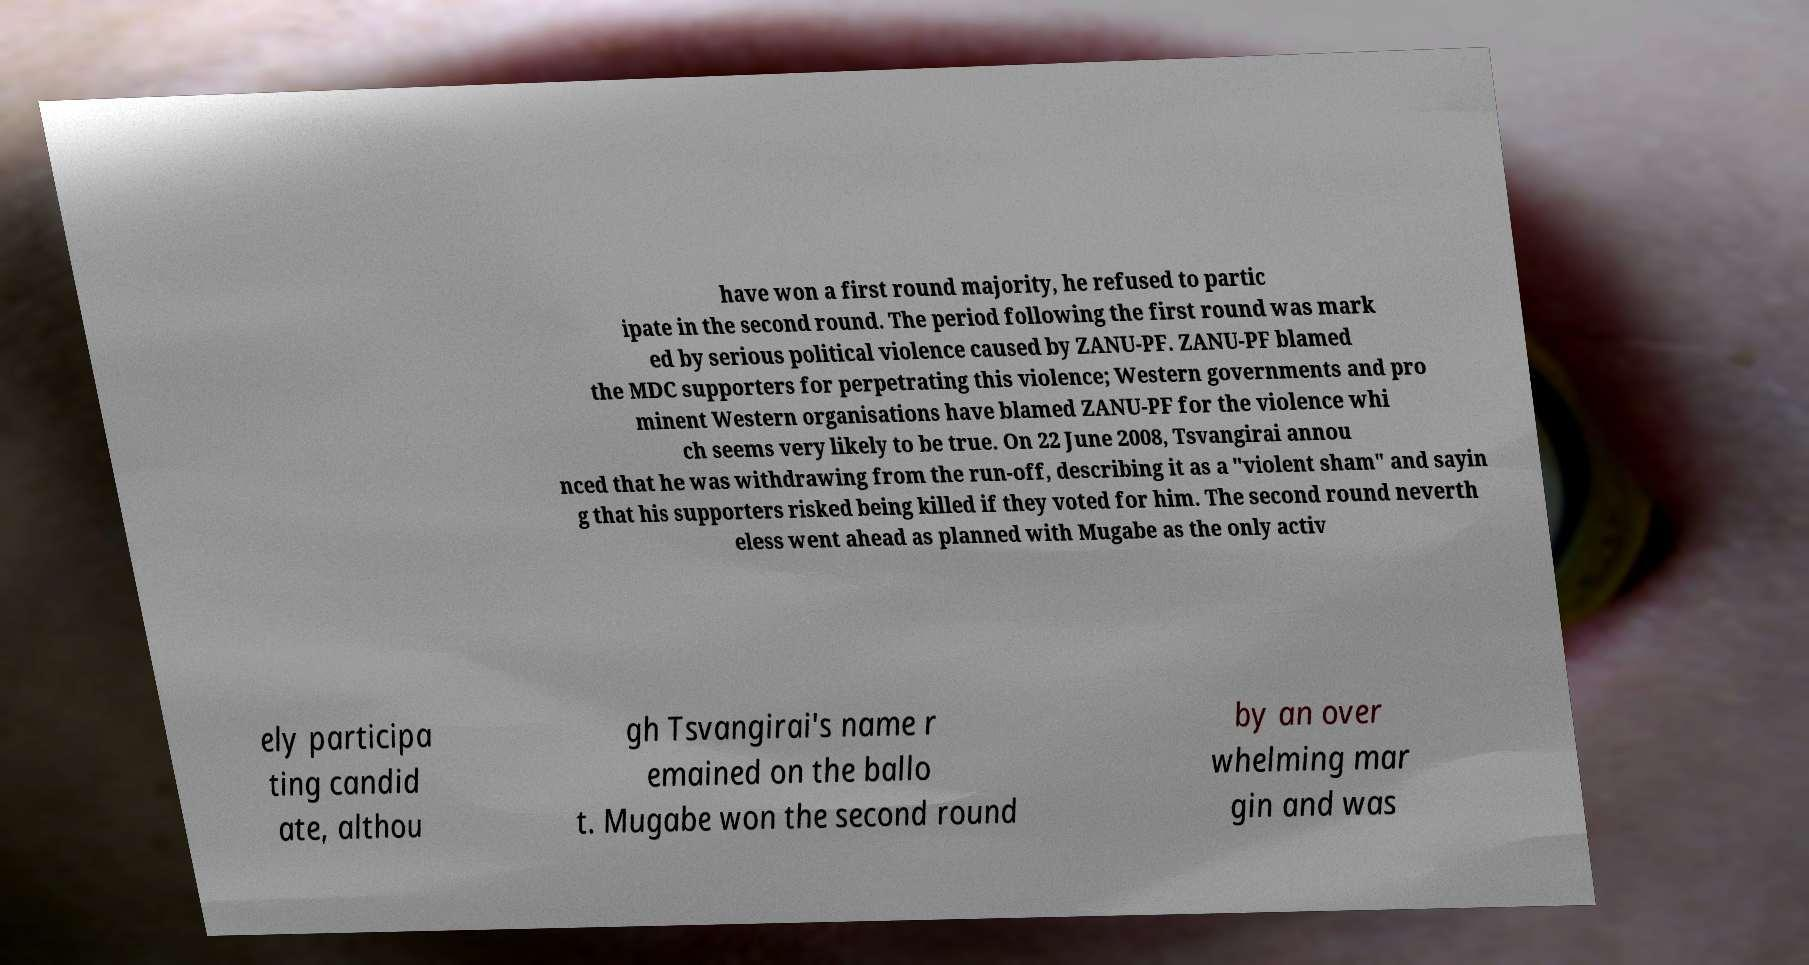Please read and relay the text visible in this image. What does it say? have won a first round majority, he refused to partic ipate in the second round. The period following the first round was mark ed by serious political violence caused by ZANU-PF. ZANU-PF blamed the MDC supporters for perpetrating this violence; Western governments and pro minent Western organisations have blamed ZANU-PF for the violence whi ch seems very likely to be true. On 22 June 2008, Tsvangirai annou nced that he was withdrawing from the run-off, describing it as a "violent sham" and sayin g that his supporters risked being killed if they voted for him. The second round neverth eless went ahead as planned with Mugabe as the only activ ely participa ting candid ate, althou gh Tsvangirai's name r emained on the ballo t. Mugabe won the second round by an over whelming mar gin and was 